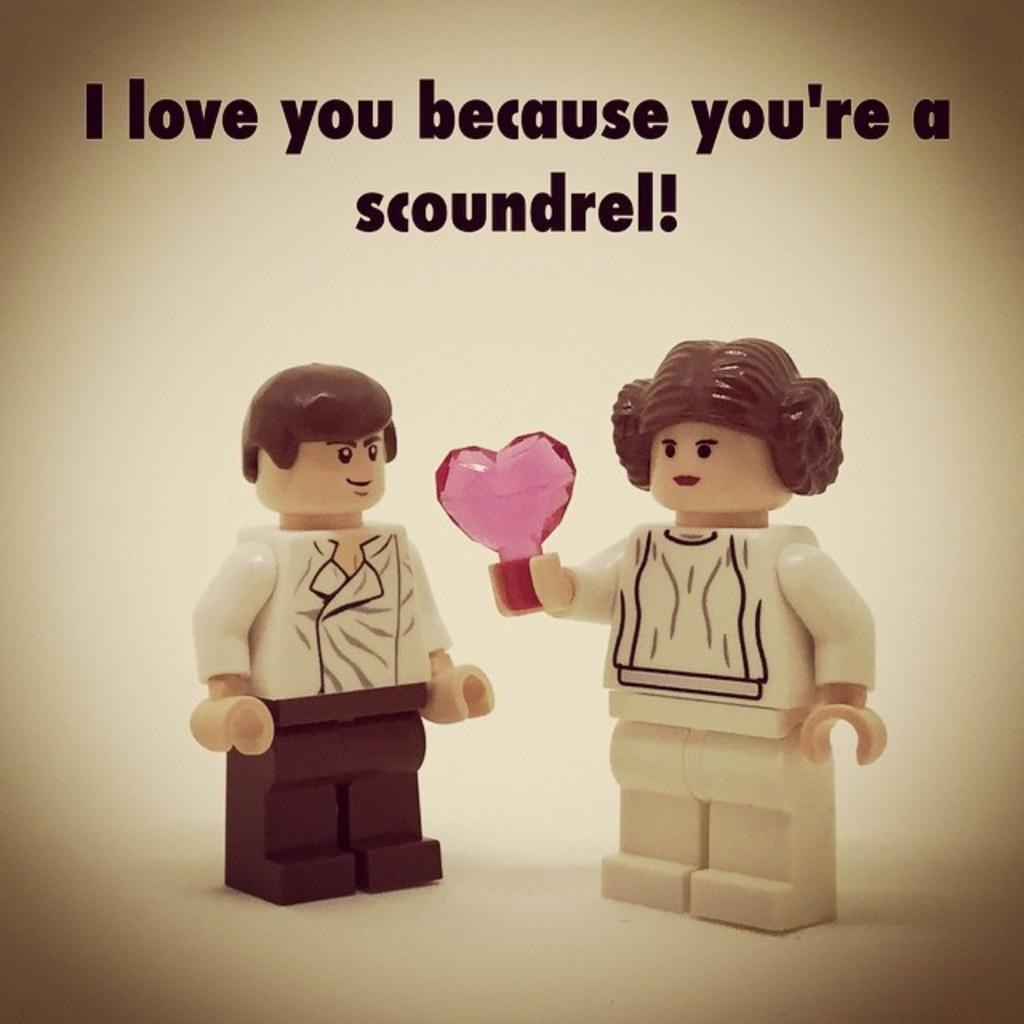What color is the background of the image? The background of the image is yellow. What can be seen in the image besides the background? There are depictions of persons in the image. Where is the text located in the image? The text is at the top of the image. How many geese are flying in the image? There are no geese present in the image. What is the tendency of the scarf in the image? There is no scarf present in the image. 